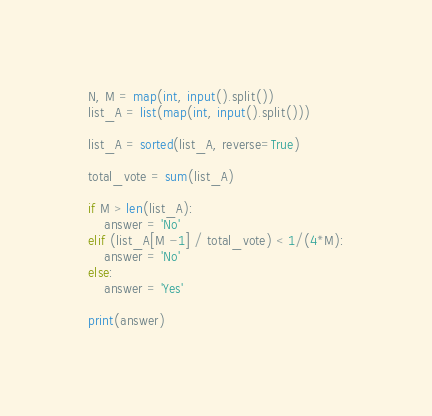<code> <loc_0><loc_0><loc_500><loc_500><_Python_>N, M = map(int, input().split())
list_A = list(map(int, input().split()))

list_A = sorted(list_A, reverse=True)

total_vote = sum(list_A)

if M > len(list_A):
    answer = 'No'
elif (list_A[M -1] / total_vote) < 1/(4*M):
    answer = 'No'
else:
    answer = 'Yes'

print(answer)
</code> 